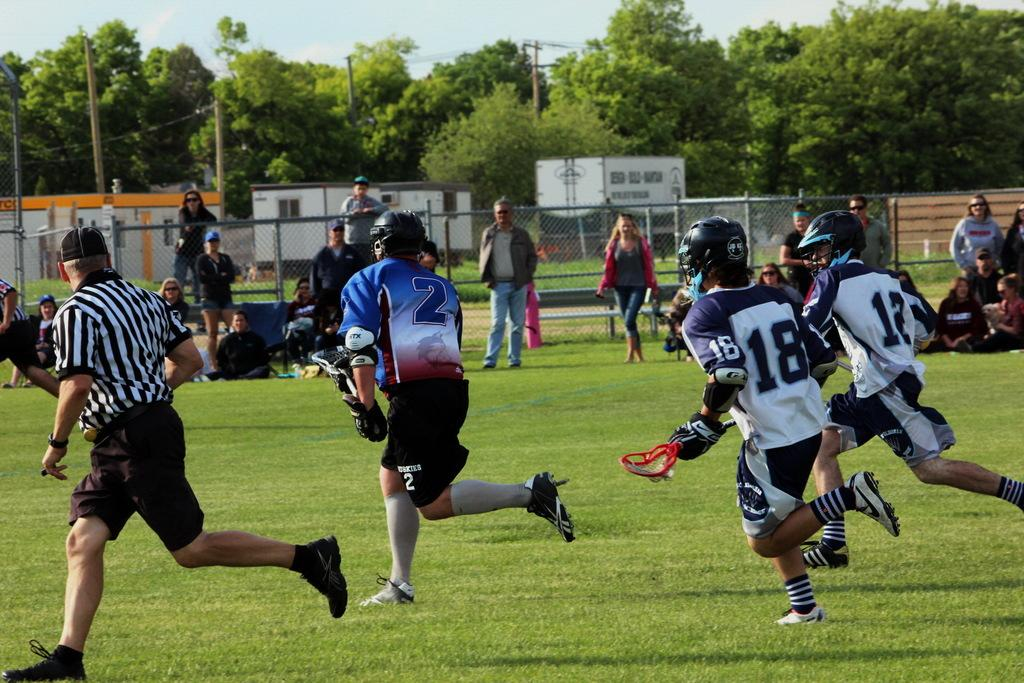What are the people in the image doing? There are four people running in the image, while others are standing and sitting on the grass. Can you describe the setting of the image? The image features an iron fence, poles, trees, and the sky is visible. How many people are sitting on the grass? There are people sitting on the grass in the image, but the exact number is not specified. What type of lettuce is being used as a cap by one of the runners in the image? There is no lettuce or cap present in the image; the people are running without any headwear. 